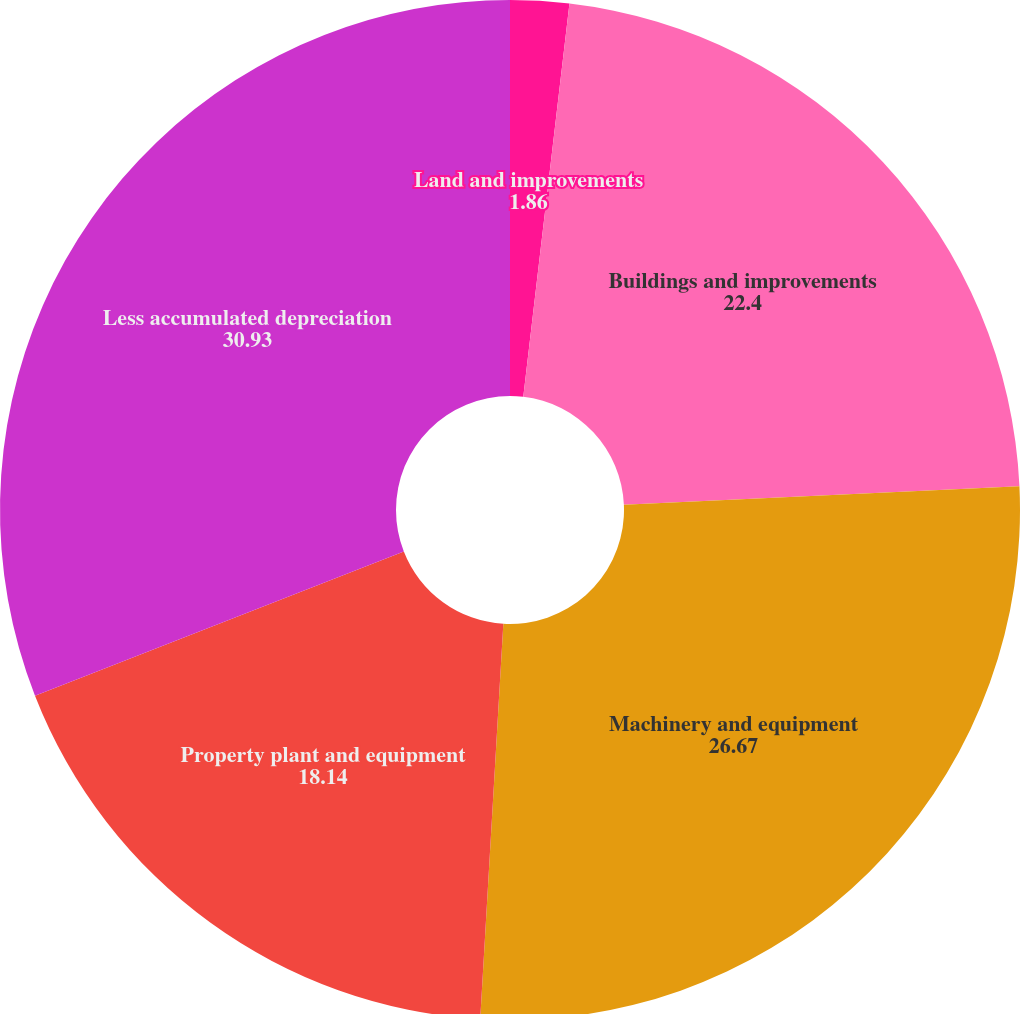Convert chart. <chart><loc_0><loc_0><loc_500><loc_500><pie_chart><fcel>Land and improvements<fcel>Buildings and improvements<fcel>Machinery and equipment<fcel>Property plant and equipment<fcel>Less accumulated depreciation<nl><fcel>1.86%<fcel>22.4%<fcel>26.67%<fcel>18.14%<fcel>30.93%<nl></chart> 